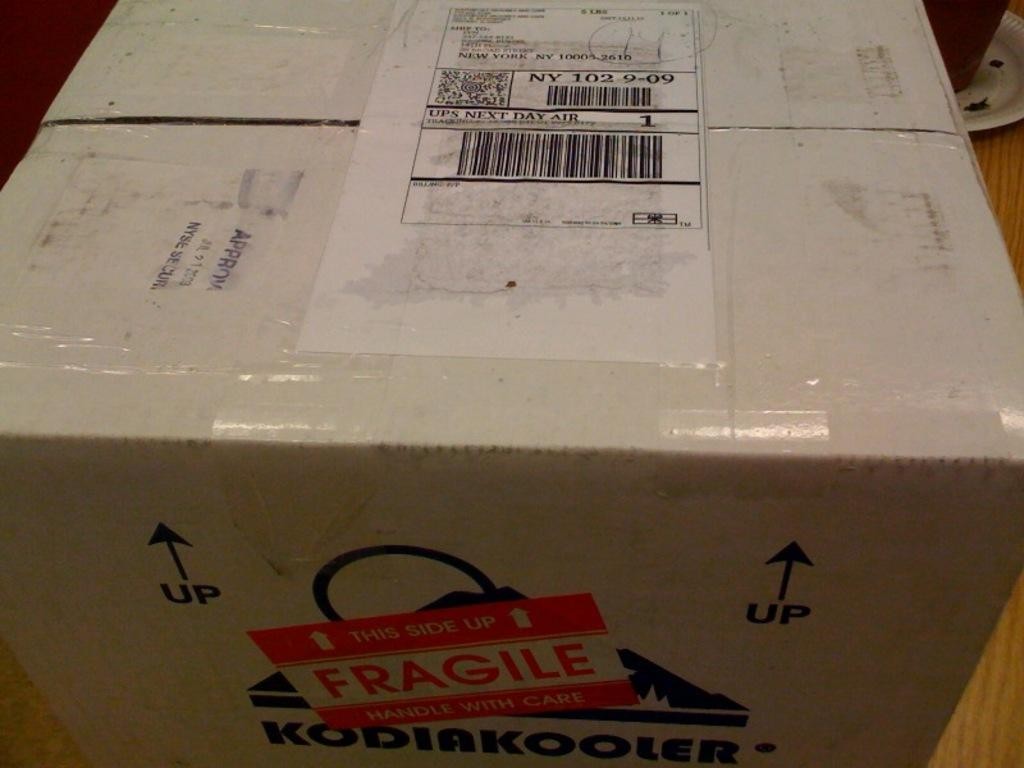What object is the main focus of the image? There is a cardboard box in the image. Can you describe the color of the cardboard box? The cardboard box is white. What color is the background of the image? The background of the image is brown. Are there any sticks visible in the image? There are no sticks present in the image. What type of error can be seen in the image? There is no error present in the image. 